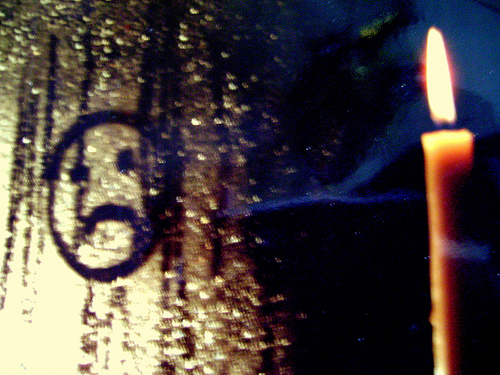<image>
Can you confirm if the candle light is next to the sad face? Yes. The candle light is positioned adjacent to the sad face, located nearby in the same general area. 